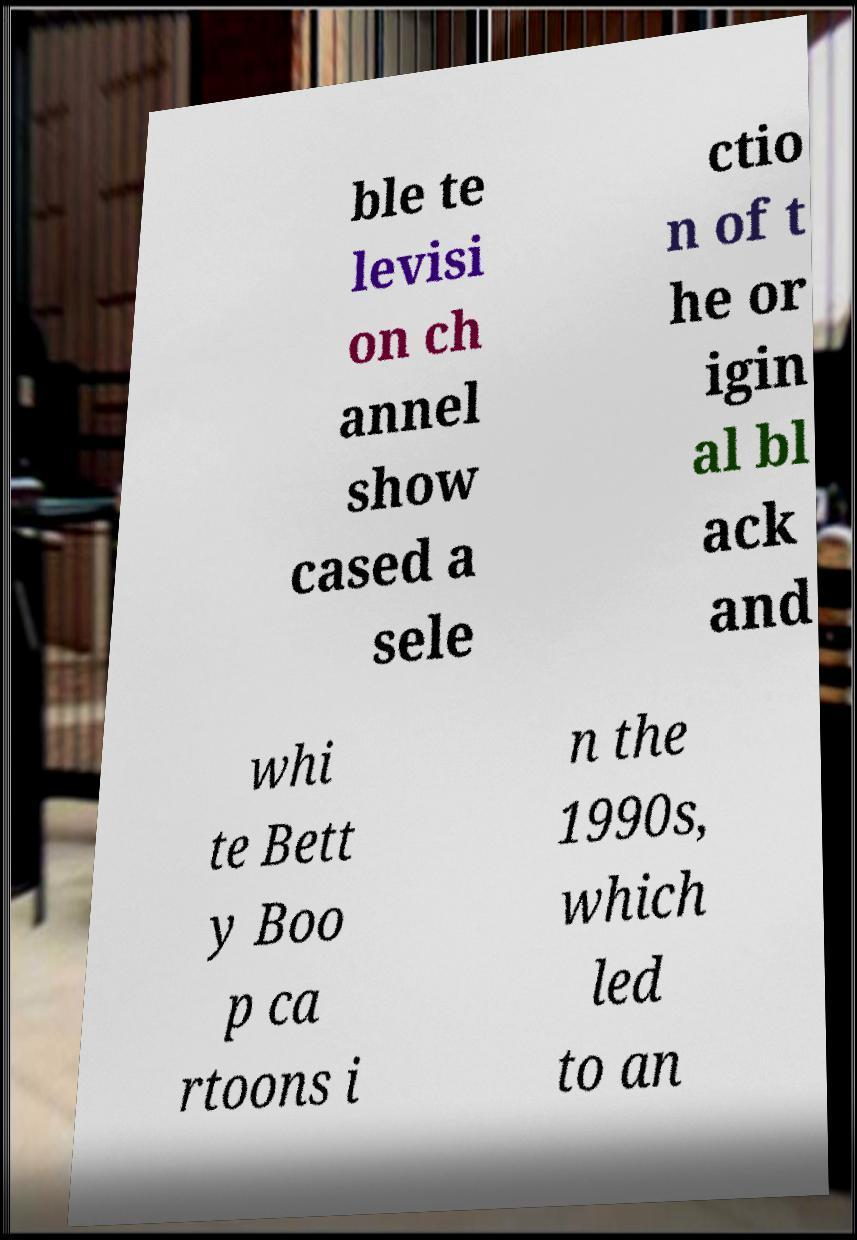For documentation purposes, I need the text within this image transcribed. Could you provide that? ble te levisi on ch annel show cased a sele ctio n of t he or igin al bl ack and whi te Bett y Boo p ca rtoons i n the 1990s, which led to an 